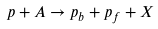<formula> <loc_0><loc_0><loc_500><loc_500>p + A \to p _ { b } + p _ { f } + X</formula> 